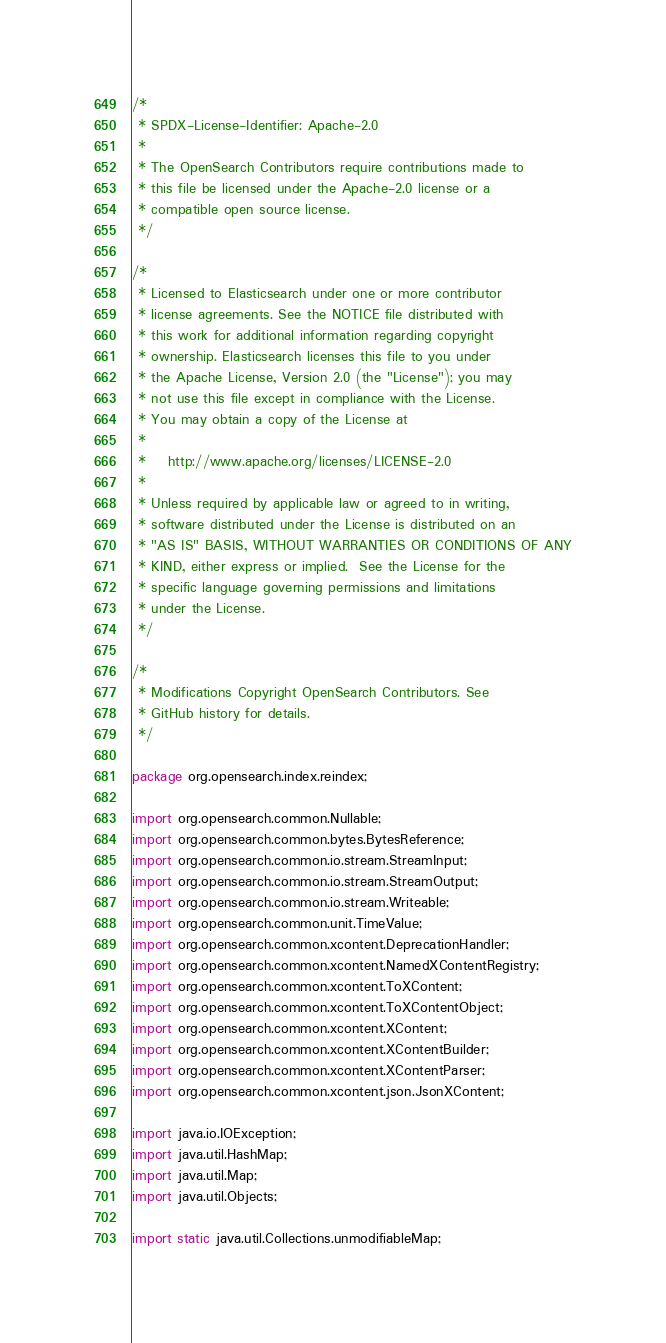Convert code to text. <code><loc_0><loc_0><loc_500><loc_500><_Java_>/*
 * SPDX-License-Identifier: Apache-2.0
 *
 * The OpenSearch Contributors require contributions made to
 * this file be licensed under the Apache-2.0 license or a
 * compatible open source license.
 */

/*
 * Licensed to Elasticsearch under one or more contributor
 * license agreements. See the NOTICE file distributed with
 * this work for additional information regarding copyright
 * ownership. Elasticsearch licenses this file to you under
 * the Apache License, Version 2.0 (the "License"); you may
 * not use this file except in compliance with the License.
 * You may obtain a copy of the License at
 *
 *    http://www.apache.org/licenses/LICENSE-2.0
 *
 * Unless required by applicable law or agreed to in writing,
 * software distributed under the License is distributed on an
 * "AS IS" BASIS, WITHOUT WARRANTIES OR CONDITIONS OF ANY
 * KIND, either express or implied.  See the License for the
 * specific language governing permissions and limitations
 * under the License.
 */

/*
 * Modifications Copyright OpenSearch Contributors. See
 * GitHub history for details.
 */

package org.opensearch.index.reindex;

import org.opensearch.common.Nullable;
import org.opensearch.common.bytes.BytesReference;
import org.opensearch.common.io.stream.StreamInput;
import org.opensearch.common.io.stream.StreamOutput;
import org.opensearch.common.io.stream.Writeable;
import org.opensearch.common.unit.TimeValue;
import org.opensearch.common.xcontent.DeprecationHandler;
import org.opensearch.common.xcontent.NamedXContentRegistry;
import org.opensearch.common.xcontent.ToXContent;
import org.opensearch.common.xcontent.ToXContentObject;
import org.opensearch.common.xcontent.XContent;
import org.opensearch.common.xcontent.XContentBuilder;
import org.opensearch.common.xcontent.XContentParser;
import org.opensearch.common.xcontent.json.JsonXContent;

import java.io.IOException;
import java.util.HashMap;
import java.util.Map;
import java.util.Objects;

import static java.util.Collections.unmodifiableMap;</code> 